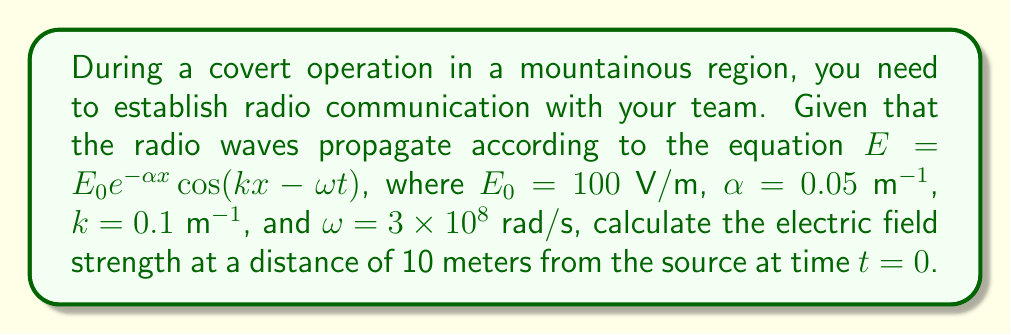Help me with this question. To solve this problem, we'll follow these steps:

1. Identify the given equation and parameters:
   $E = E_0 e^{-\alpha x} \cos(kx - \omega t)$
   $E_0 = 100$ V/m
   $\alpha = 0.05$ m^(-1)
   $k = 0.1$ m^(-1)
   $\omega = 3 \times 10^8$ rad/s
   $x = 10$ m
   $t = 0$ s

2. Substitute the values into the equation:
   $E = 100 e^{-0.05 \cdot 10} \cos(0.1 \cdot 10 - 3 \times 10^8 \cdot 0)$

3. Simplify the exponent:
   $e^{-0.05 \cdot 10} = e^{-0.5}$

4. Simplify the cosine argument:
   $\cos(0.1 \cdot 10 - 0) = \cos(1)$

5. Calculate the electric field strength:
   $E = 100 \cdot e^{-0.5} \cdot \cos(1)$

6. Evaluate the expression:
   $E \approx 100 \cdot 0.6065 \cdot 0.5403 \approx 32.76$ V/m
Answer: $32.76$ V/m 